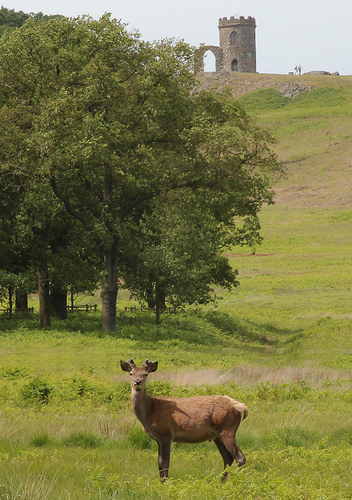<image>
Is there a castle above the deer? No. The castle is not positioned above the deer. The vertical arrangement shows a different relationship. 